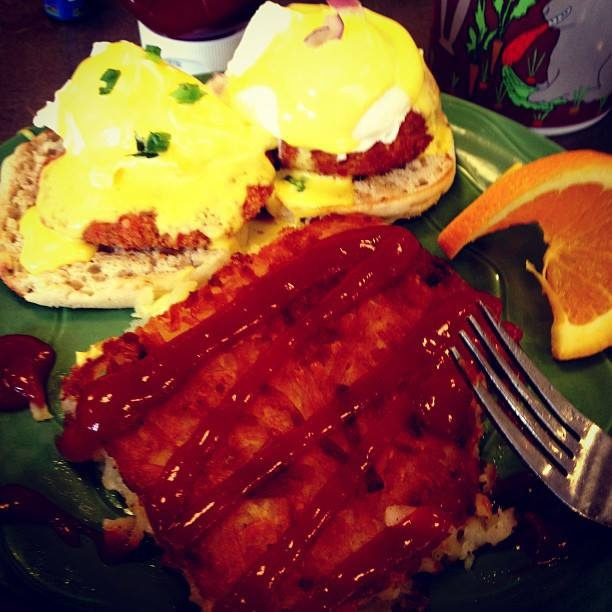Describe the objects in this image and their specific colors. I can see sandwich in black, maroon, and brown tones, sandwich in black, yellow, khaki, tan, and red tones, sandwich in black, yellow, khaki, lightyellow, and orange tones, cup in black, gray, maroon, and darkgreen tones, and orange in black, red, orange, and brown tones in this image. 